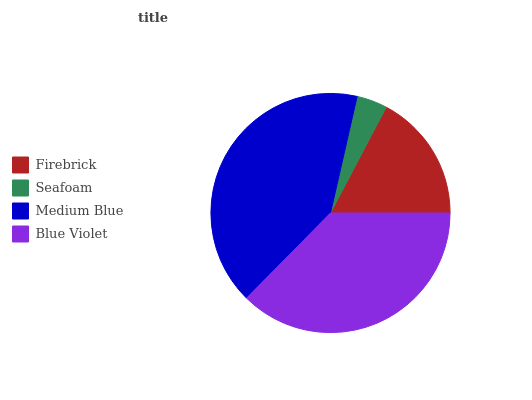Is Seafoam the minimum?
Answer yes or no. Yes. Is Medium Blue the maximum?
Answer yes or no. Yes. Is Medium Blue the minimum?
Answer yes or no. No. Is Seafoam the maximum?
Answer yes or no. No. Is Medium Blue greater than Seafoam?
Answer yes or no. Yes. Is Seafoam less than Medium Blue?
Answer yes or no. Yes. Is Seafoam greater than Medium Blue?
Answer yes or no. No. Is Medium Blue less than Seafoam?
Answer yes or no. No. Is Blue Violet the high median?
Answer yes or no. Yes. Is Firebrick the low median?
Answer yes or no. Yes. Is Medium Blue the high median?
Answer yes or no. No. Is Seafoam the low median?
Answer yes or no. No. 